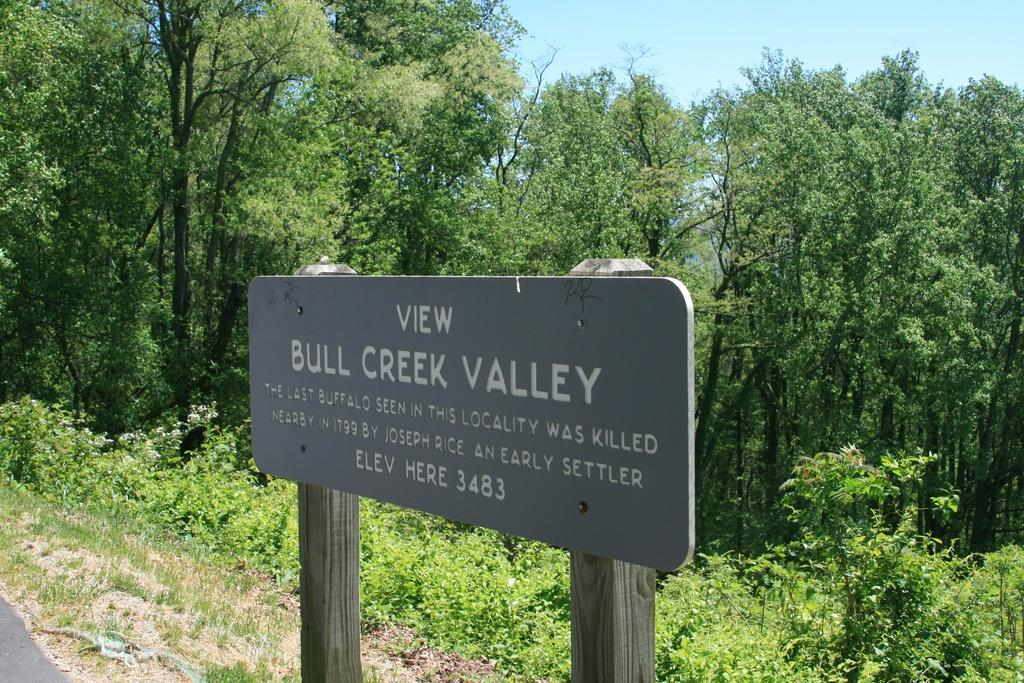What is the main object in the foreground of the image? There is an information board in the image. What can be seen in the background of the image? There are trees, plants, and the sky visible in the background of the image. Is there a volcano visible in the image? No, there is no volcano present in the image. What type of water can be seen in the image? There is no water visible in the image. 